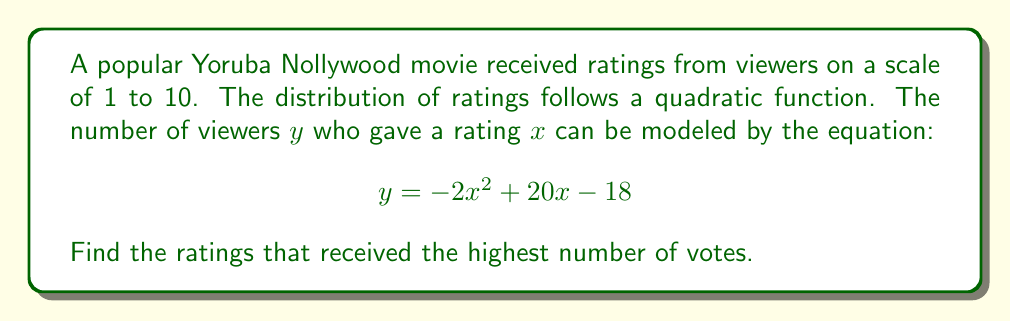What is the answer to this math problem? To find the ratings that received the highest number of votes, we need to find the maximum point of the quadratic function. This corresponds to finding the roots of the derivative of the function.

1) First, let's find the derivative of the function:
   $$\frac{dy}{dx} = -4x + 20$$

2) The maximum point occurs where the derivative equals zero:
   $$-4x + 20 = 0$$

3) Solve for x:
   $$-4x = -20$$
   $$x = 5$$

4) To confirm this is a maximum (not a minimum), we can check the second derivative:
   $$\frac{d^2y}{dx^2} = -4$$
   Since this is negative, we confirm it's a maximum.

5) The x-coordinate of the maximum point represents the rating that received the highest number of votes.

6) We can find the y-coordinate (maximum number of votes) by plugging x = 5 into the original equation:
   $$y = -2(5)^2 + 20(5) - 18 = -50 + 100 - 18 = 32$$

Therefore, the rating of 5 received the highest number of votes (32 votes).
Answer: The rating that received the highest number of votes is 5. 